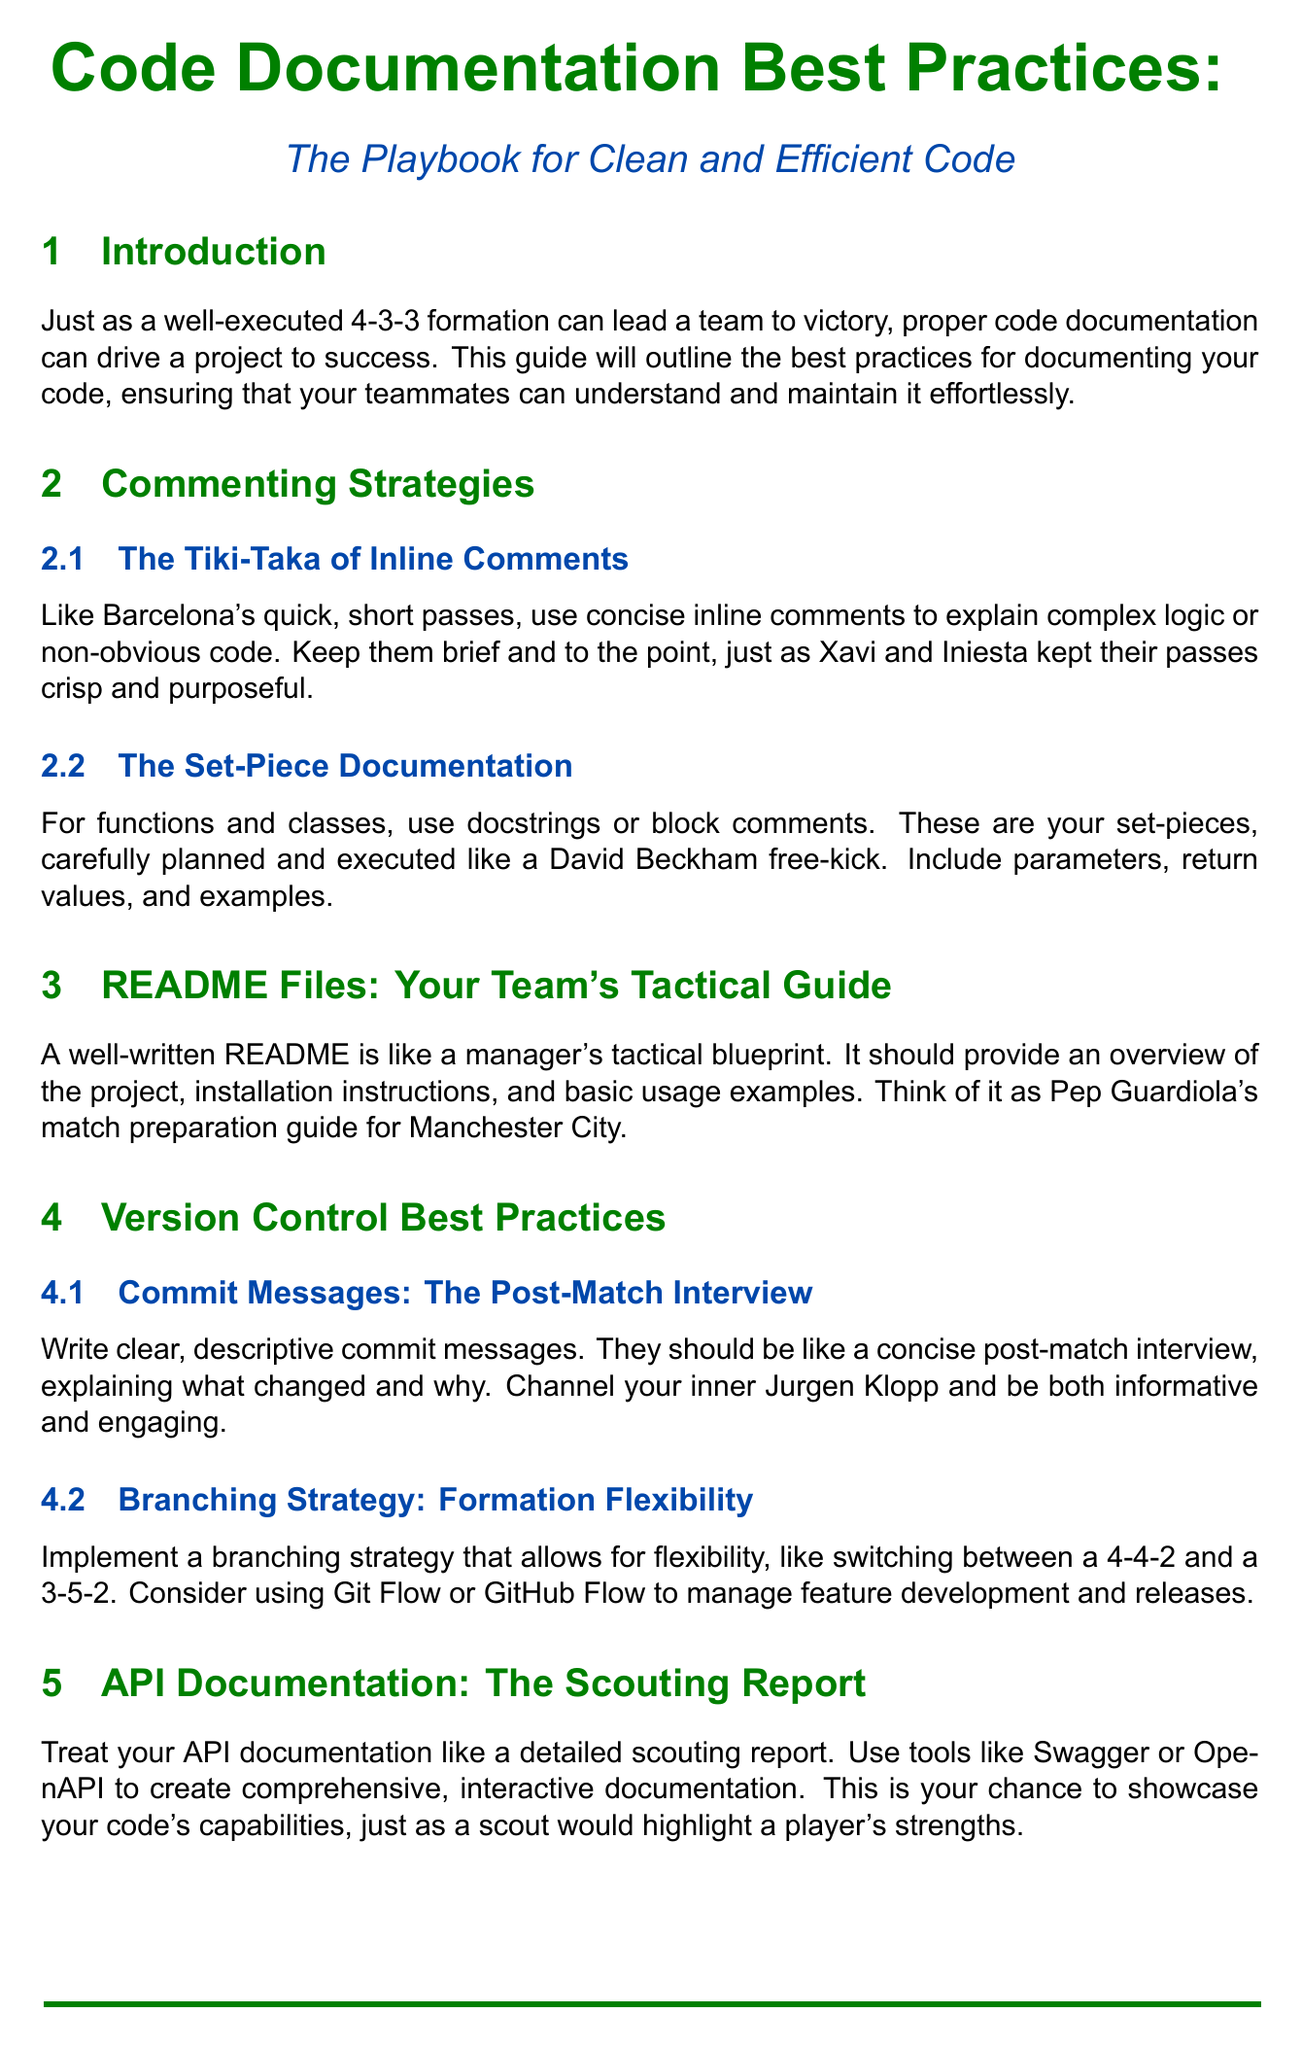What is the title of the document? The title is provided at the beginning of the document and summarizes its content on code documentation best practices.
Answer: Code Documentation Best Practices: The Playbook for Clean and Efficient Code What formation is compared to proper code documentation in the introduction? The introduction compares a specific soccer formation to the importance of code documentation, supporting the theme of teamwork and strategy.
Answer: 4-3-3 Which famous soccer player is referenced in the section about set-piece documentation? The content refers to a well-known player known for his free-kick abilities when discussing proper documentation practices for functions and classes.
Answer: David Beckham What is emphasized as important in the section on commit messages? The section discusses the quality of commit messages and likens them to an informative sport-related dialogue, highlighting the need for clarity.
Answer: Clear, descriptive What role do automated documentation tools play according to the document? The document likens these tools to a system in soccer that helps ensure compliance and accuracy in documentation, reflecting their importance.
Answer: Video Assistant Referee (VAR) What should a README file include according to best practices? The document outlines components that should be included in a README file, highlighting its importance within project documentation.
Answer: Overview, installation instructions, usage examples What is the purpose of establishing a code style guide? The content explains a specific reasoning behind having a consistent coding style to aid in teamwork and understanding among developers.
Answer: Consistency helps readability What is encouraged as part of the peer review process? The document details a practice that is suggested to improve code and documentation quality through collaborative evaluation among team members.
Answer: Feedback and suggestions What is continuous integration likened to in the context of this document? This section makes a comparison to a common practice in sports training that helps maintain readiness, illustrating the importance of integration in documentation.
Answer: Training regimen 